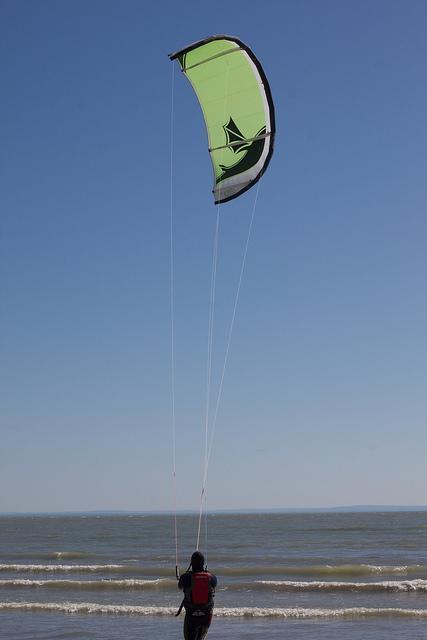How many people are in this photo?
Give a very brief answer. 1. 